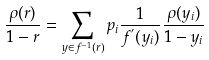Convert formula to latex. <formula><loc_0><loc_0><loc_500><loc_500>\frac { \rho ( r ) } { 1 - r } = \sum _ { y \in f ^ { - 1 } ( r ) } p _ { i } \frac { 1 } { f ^ { ^ { \prime } } ( y _ { i } ) } \frac { \rho ( y _ { i } ) } { 1 - y _ { i } }</formula> 